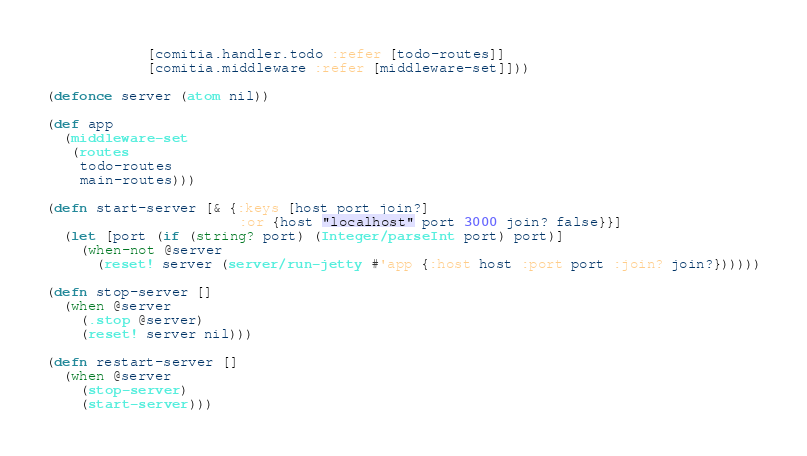Convert code to text. <code><loc_0><loc_0><loc_500><loc_500><_Clojure_>            [comitia.handler.todo :refer [todo-routes]]
            [comitia.middleware :refer [middleware-set]]))

(defonce server (atom nil))

(def app
  (middleware-set
   (routes
    todo-routes
    main-routes)))

(defn start-server [& {:keys [host port join?]
                       :or {host "localhost" port 3000 join? false}}]
  (let [port (if (string? port) (Integer/parseInt port) port)]
    (when-not @server
      (reset! server (server/run-jetty #'app {:host host :port port :join? join?})))))

(defn stop-server []
  (when @server
    (.stop @server)
    (reset! server nil)))

(defn restart-server []
  (when @server
    (stop-server)
    (start-server)))
</code> 